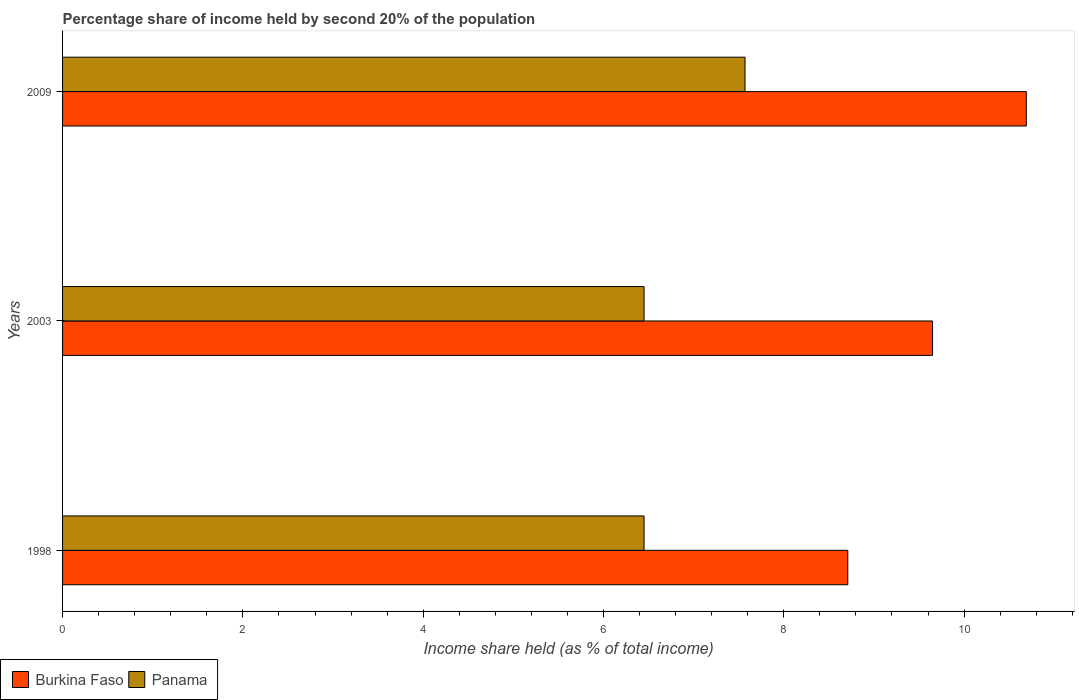How many groups of bars are there?
Keep it short and to the point. 3. How many bars are there on the 2nd tick from the top?
Ensure brevity in your answer.  2. What is the share of income held by second 20% of the population in Burkina Faso in 2003?
Provide a succinct answer. 9.65. Across all years, what is the maximum share of income held by second 20% of the population in Burkina Faso?
Make the answer very short. 10.69. Across all years, what is the minimum share of income held by second 20% of the population in Burkina Faso?
Provide a succinct answer. 8.71. In which year was the share of income held by second 20% of the population in Burkina Faso maximum?
Make the answer very short. 2009. What is the total share of income held by second 20% of the population in Panama in the graph?
Provide a succinct answer. 20.47. What is the difference between the share of income held by second 20% of the population in Panama in 2003 and that in 2009?
Your answer should be very brief. -1.12. What is the difference between the share of income held by second 20% of the population in Burkina Faso in 2009 and the share of income held by second 20% of the population in Panama in 1998?
Make the answer very short. 4.24. What is the average share of income held by second 20% of the population in Panama per year?
Your answer should be very brief. 6.82. In the year 2009, what is the difference between the share of income held by second 20% of the population in Panama and share of income held by second 20% of the population in Burkina Faso?
Make the answer very short. -3.12. What is the ratio of the share of income held by second 20% of the population in Burkina Faso in 2003 to that in 2009?
Ensure brevity in your answer.  0.9. What is the difference between the highest and the second highest share of income held by second 20% of the population in Panama?
Offer a very short reply. 1.12. What is the difference between the highest and the lowest share of income held by second 20% of the population in Panama?
Offer a very short reply. 1.12. What does the 1st bar from the top in 2009 represents?
Keep it short and to the point. Panama. What does the 2nd bar from the bottom in 1998 represents?
Make the answer very short. Panama. How many years are there in the graph?
Your response must be concise. 3. What is the difference between two consecutive major ticks on the X-axis?
Offer a very short reply. 2. Does the graph contain any zero values?
Keep it short and to the point. No. Does the graph contain grids?
Offer a terse response. No. How many legend labels are there?
Make the answer very short. 2. What is the title of the graph?
Ensure brevity in your answer.  Percentage share of income held by second 20% of the population. Does "Singapore" appear as one of the legend labels in the graph?
Your answer should be very brief. No. What is the label or title of the X-axis?
Give a very brief answer. Income share held (as % of total income). What is the label or title of the Y-axis?
Your response must be concise. Years. What is the Income share held (as % of total income) in Burkina Faso in 1998?
Your answer should be compact. 8.71. What is the Income share held (as % of total income) in Panama in 1998?
Offer a very short reply. 6.45. What is the Income share held (as % of total income) of Burkina Faso in 2003?
Give a very brief answer. 9.65. What is the Income share held (as % of total income) in Panama in 2003?
Your response must be concise. 6.45. What is the Income share held (as % of total income) of Burkina Faso in 2009?
Offer a terse response. 10.69. What is the Income share held (as % of total income) in Panama in 2009?
Your response must be concise. 7.57. Across all years, what is the maximum Income share held (as % of total income) in Burkina Faso?
Offer a very short reply. 10.69. Across all years, what is the maximum Income share held (as % of total income) in Panama?
Give a very brief answer. 7.57. Across all years, what is the minimum Income share held (as % of total income) in Burkina Faso?
Your response must be concise. 8.71. Across all years, what is the minimum Income share held (as % of total income) in Panama?
Your answer should be compact. 6.45. What is the total Income share held (as % of total income) of Burkina Faso in the graph?
Your answer should be very brief. 29.05. What is the total Income share held (as % of total income) in Panama in the graph?
Your response must be concise. 20.47. What is the difference between the Income share held (as % of total income) in Burkina Faso in 1998 and that in 2003?
Your answer should be very brief. -0.94. What is the difference between the Income share held (as % of total income) of Panama in 1998 and that in 2003?
Provide a short and direct response. 0. What is the difference between the Income share held (as % of total income) in Burkina Faso in 1998 and that in 2009?
Keep it short and to the point. -1.98. What is the difference between the Income share held (as % of total income) of Panama in 1998 and that in 2009?
Make the answer very short. -1.12. What is the difference between the Income share held (as % of total income) of Burkina Faso in 2003 and that in 2009?
Your response must be concise. -1.04. What is the difference between the Income share held (as % of total income) of Panama in 2003 and that in 2009?
Make the answer very short. -1.12. What is the difference between the Income share held (as % of total income) of Burkina Faso in 1998 and the Income share held (as % of total income) of Panama in 2003?
Give a very brief answer. 2.26. What is the difference between the Income share held (as % of total income) of Burkina Faso in 1998 and the Income share held (as % of total income) of Panama in 2009?
Make the answer very short. 1.14. What is the difference between the Income share held (as % of total income) in Burkina Faso in 2003 and the Income share held (as % of total income) in Panama in 2009?
Your answer should be compact. 2.08. What is the average Income share held (as % of total income) of Burkina Faso per year?
Your answer should be compact. 9.68. What is the average Income share held (as % of total income) of Panama per year?
Ensure brevity in your answer.  6.82. In the year 1998, what is the difference between the Income share held (as % of total income) in Burkina Faso and Income share held (as % of total income) in Panama?
Your answer should be compact. 2.26. In the year 2003, what is the difference between the Income share held (as % of total income) of Burkina Faso and Income share held (as % of total income) of Panama?
Keep it short and to the point. 3.2. In the year 2009, what is the difference between the Income share held (as % of total income) of Burkina Faso and Income share held (as % of total income) of Panama?
Provide a succinct answer. 3.12. What is the ratio of the Income share held (as % of total income) in Burkina Faso in 1998 to that in 2003?
Ensure brevity in your answer.  0.9. What is the ratio of the Income share held (as % of total income) of Panama in 1998 to that in 2003?
Give a very brief answer. 1. What is the ratio of the Income share held (as % of total income) in Burkina Faso in 1998 to that in 2009?
Provide a succinct answer. 0.81. What is the ratio of the Income share held (as % of total income) in Panama in 1998 to that in 2009?
Ensure brevity in your answer.  0.85. What is the ratio of the Income share held (as % of total income) in Burkina Faso in 2003 to that in 2009?
Provide a short and direct response. 0.9. What is the ratio of the Income share held (as % of total income) in Panama in 2003 to that in 2009?
Make the answer very short. 0.85. What is the difference between the highest and the second highest Income share held (as % of total income) of Panama?
Ensure brevity in your answer.  1.12. What is the difference between the highest and the lowest Income share held (as % of total income) of Burkina Faso?
Give a very brief answer. 1.98. What is the difference between the highest and the lowest Income share held (as % of total income) of Panama?
Give a very brief answer. 1.12. 